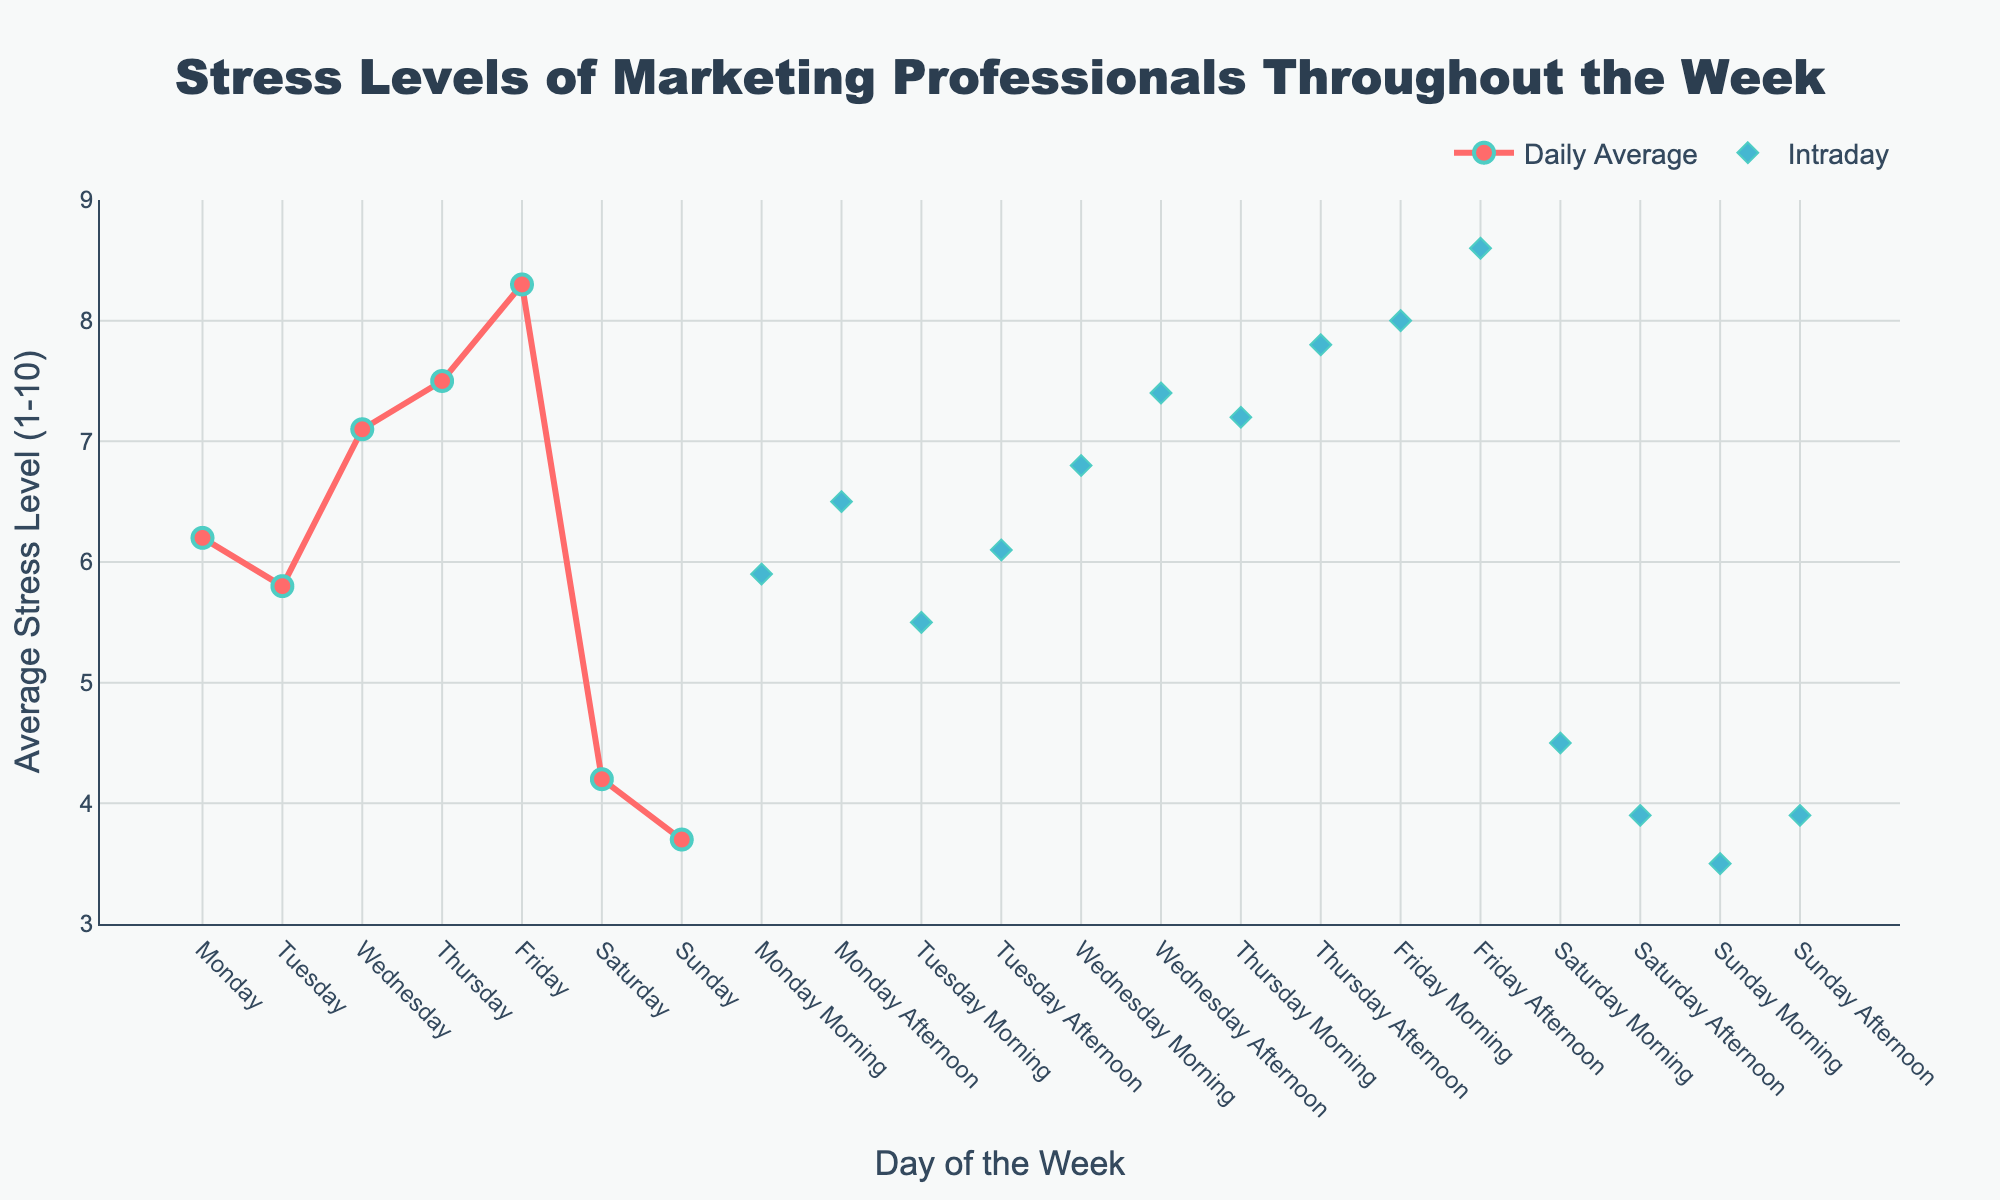What's the day with the highest average stress level? The day with the highest average stress level is indicated by the tallest line mark in the 'Daily Average' series. By referring to the figure, Friday stands out with the highest value.
Answer: Friday What is the average stress level on Monday morning? Check the 'Intraday' series for the marker corresponding to 'Monday Morning'. The figure shows that Monday morning has a marker indicating an average stress level of 5.9.
Answer: 5.9 How does the average stress level on Thursday afternoon compare to Thursday morning? Look at both 'Intraday' markers for 'Thursday Morning' and 'Thursday Afternoon'. The average stress level rises from 7.2 in the morning to 7.8 in the afternoon.
Answer: It increases What is the difference in average stress levels between the highest and lowest weekdays? Identify the highest and lowest daily stress levels from Monday to Friday. The highest is on Friday (8.3) and the lowest is on Tuesday (5.8). The difference is 8.3 - 5.8 = 2.5.
Answer: 2.5 Which period shows the lowest stress level throughout the week? The lowest average stress level can be seen by identifying the shortest marker in the 'Intraday' series. 'Sunday Morning' has the lowest stress level at 3.5.
Answer: Sunday Morning Which day has the greatest difference in stress levels between morning and afternoon? Compare the intraday morning and afternoon stress levels for each day. Thursday shows the greatest difference with morning at 7.2 and afternoon at 7.8, giving a difference of 0.6.
Answer: Thursday Which is higher, the average stress level on Saturday afternoon or Sunday afternoon? Examine the 'Intraday' markers for 'Saturday Afternoon' (3.9) and 'Sunday Afternoon' (3.9). Both periods have the same stress level.
Answer: They are equal Calculate the average stress level for weekends (Saturday and Sunday) by combining their average values. Weekend average stress levels are as follows: Saturday (4.2) and Sunday (3.7). Calculate the mean: (4.2 + 3.7) / 2 = 3.95.
Answer: 3.95 Is Monday morning stress level higher than Tuesday morning? By checking the 'Intraday' series, Monday morning has a stress level of 5.9 and Tuesday morning has 5.5. 5.9 is higher than 5.5.
Answer: Yes Compare the stress levels on Wednesday afternoon and Friday morning. Which one is higher? Refer to the 'Intraday' series: Wednesday afternoon (7.4) and Friday morning (8.0). Friday morning is higher.
Answer: Friday morning 